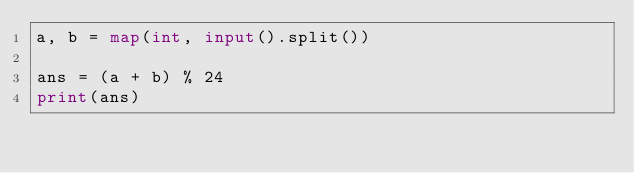<code> <loc_0><loc_0><loc_500><loc_500><_Python_>a, b = map(int, input().split())

ans = (a + b) % 24
print(ans)
</code> 